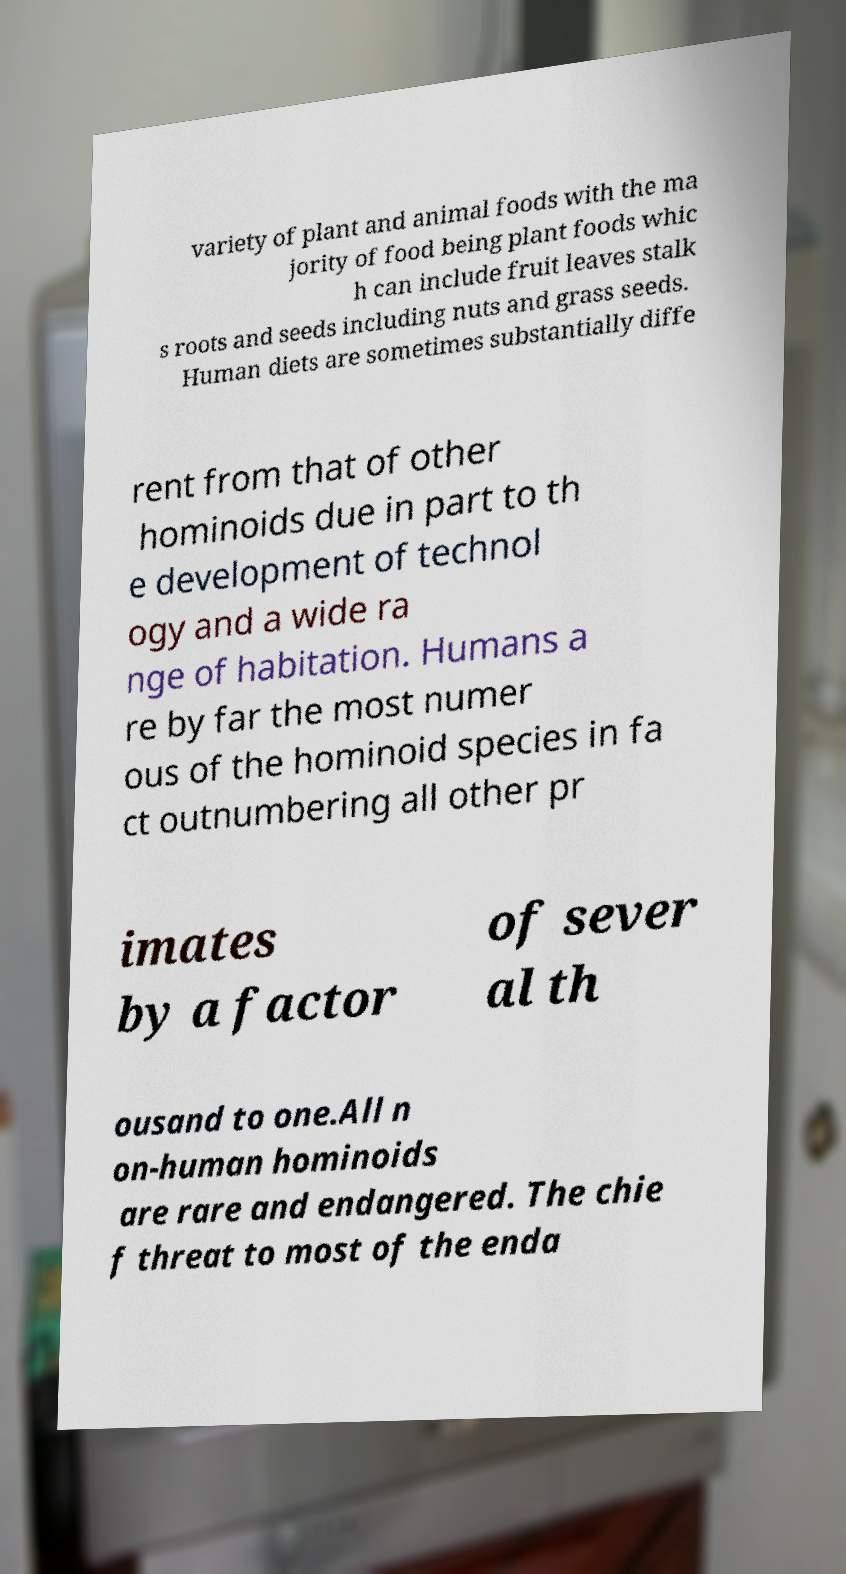Could you assist in decoding the text presented in this image and type it out clearly? variety of plant and animal foods with the ma jority of food being plant foods whic h can include fruit leaves stalk s roots and seeds including nuts and grass seeds. Human diets are sometimes substantially diffe rent from that of other hominoids due in part to th e development of technol ogy and a wide ra nge of habitation. Humans a re by far the most numer ous of the hominoid species in fa ct outnumbering all other pr imates by a factor of sever al th ousand to one.All n on-human hominoids are rare and endangered. The chie f threat to most of the enda 